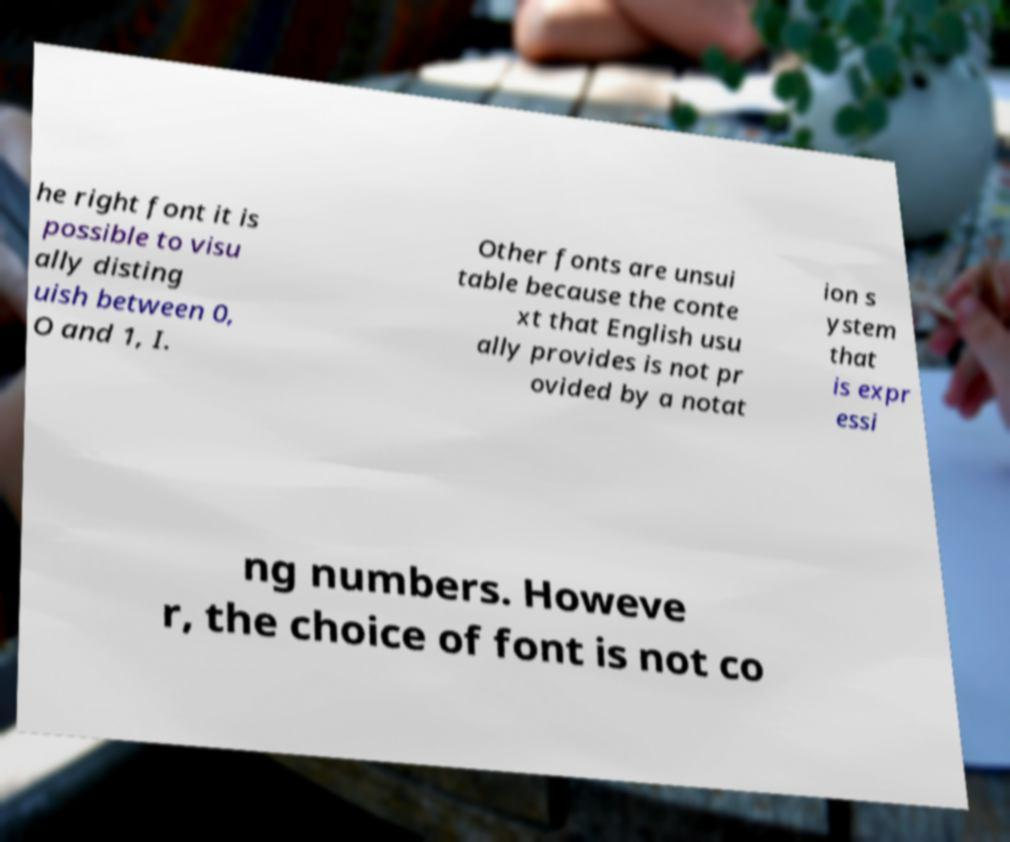There's text embedded in this image that I need extracted. Can you transcribe it verbatim? he right font it is possible to visu ally disting uish between 0, O and 1, I. Other fonts are unsui table because the conte xt that English usu ally provides is not pr ovided by a notat ion s ystem that is expr essi ng numbers. Howeve r, the choice of font is not co 